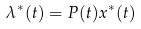Convert formula to latex. <formula><loc_0><loc_0><loc_500><loc_500>{ \lambda } ^ { \ast } ( t ) = P ( t ) x ^ { \ast } ( t )</formula> 